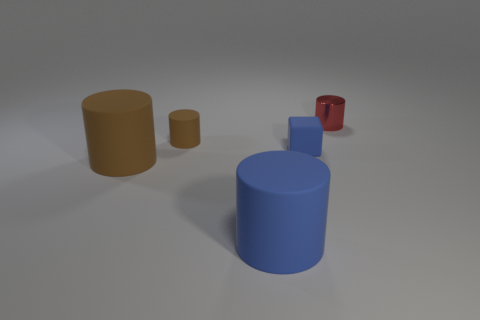Is the number of brown matte things behind the small brown thing greater than the number of blue matte things that are right of the small shiny cylinder?
Ensure brevity in your answer.  No. The blue matte cylinder has what size?
Your response must be concise. Large. Does the cylinder that is on the right side of the block have the same color as the small cube?
Your answer should be compact. No. Is there any other thing that has the same shape as the tiny blue object?
Provide a succinct answer. No. There is a small matte object that is to the left of the big blue cylinder; are there any brown objects on the right side of it?
Keep it short and to the point. No. Are there fewer small matte cylinders that are behind the tiny red object than blue rubber cylinders that are right of the blue block?
Ensure brevity in your answer.  No. How big is the object to the left of the small rubber thing that is on the left side of the tiny rubber thing right of the blue cylinder?
Ensure brevity in your answer.  Large. There is a matte thing that is on the right side of the blue matte cylinder; does it have the same size as the small brown thing?
Your answer should be very brief. Yes. What number of other things are the same material as the big brown thing?
Provide a succinct answer. 3. Are there more small cylinders than blue rubber blocks?
Keep it short and to the point. Yes. 